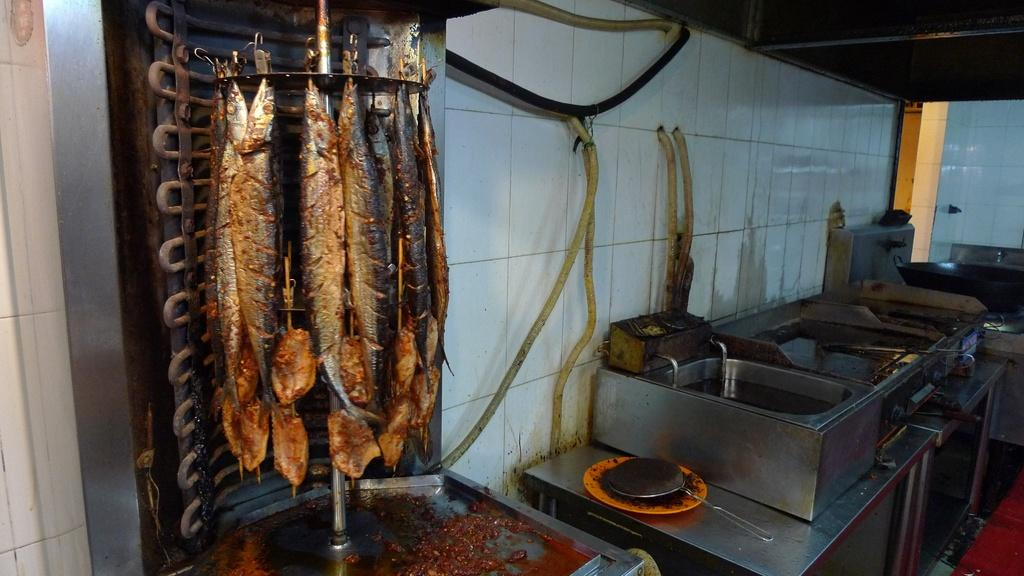What type of animals can be seen in the image? There are fishes in the image. What objects are on the right side of the image? There are iron boxes on the right side of the image. What is the tendency of the snails in the image? There are no snails present in the image, so it's not possible to determine their tendency. 